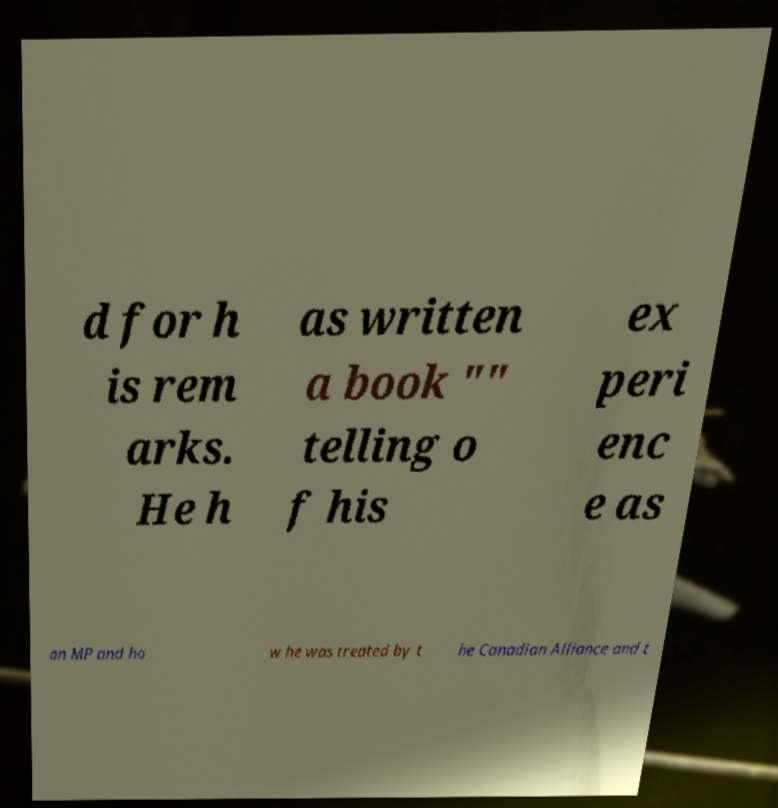Please read and relay the text visible in this image. What does it say? d for h is rem arks. He h as written a book "" telling o f his ex peri enc e as an MP and ho w he was treated by t he Canadian Alliance and t 